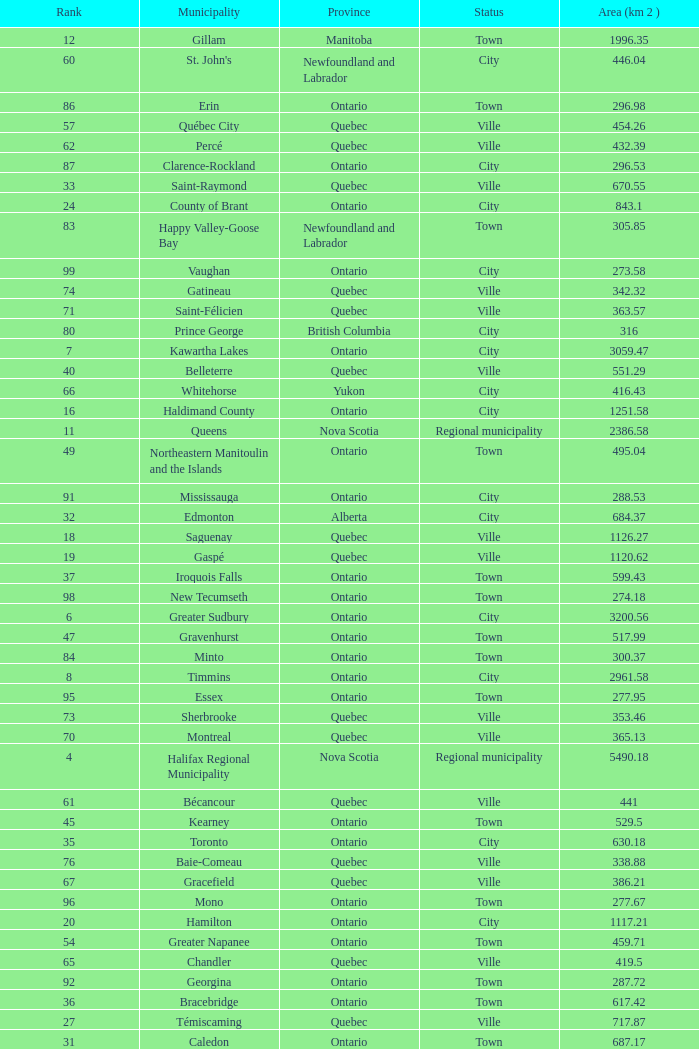What is the listed Status that has the Province of Ontario and Rank of 86? Town. 